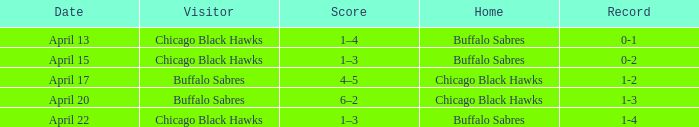When has a Record of 1-3? April 20. 